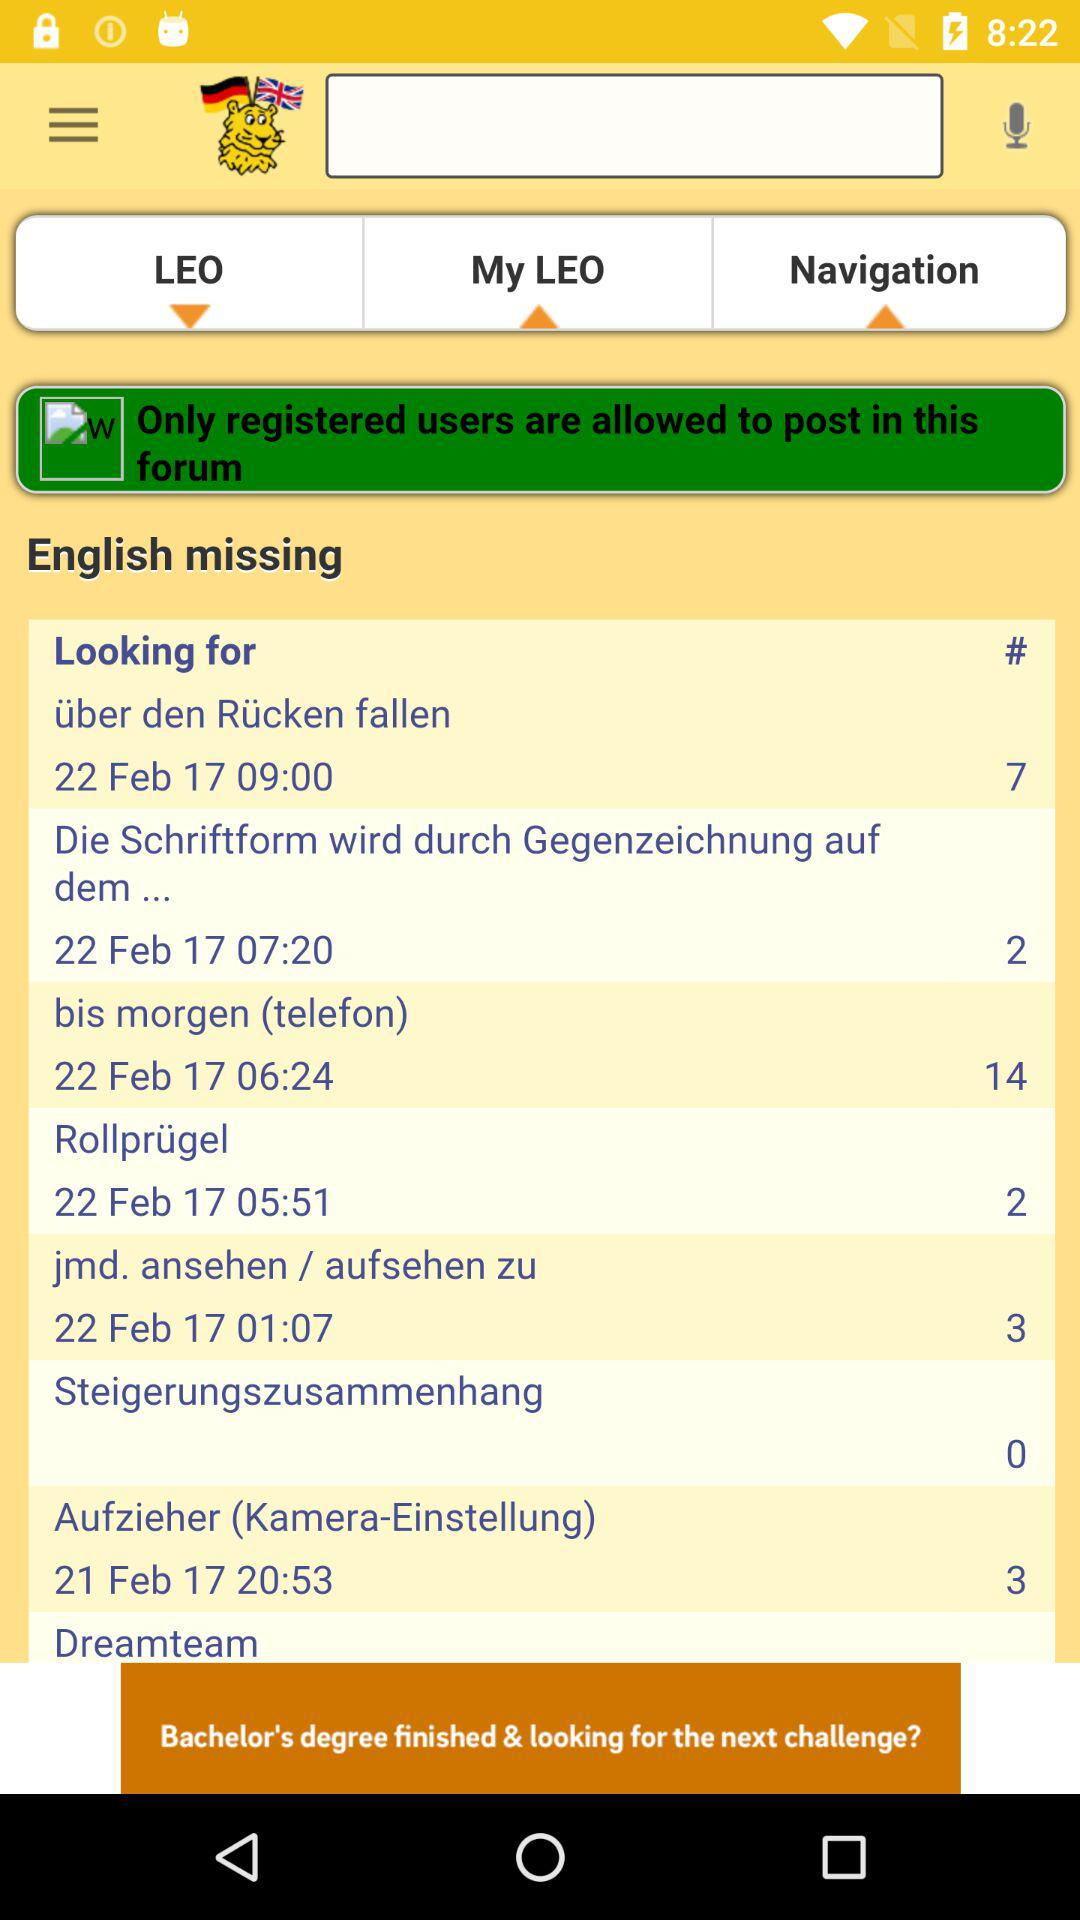What is the date? The dates are February 22 and February 21. 